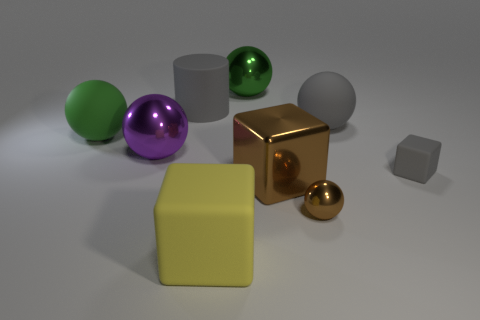There is a gray rubber thing that is in front of the metallic ball that is left of the yellow matte object; how big is it?
Offer a very short reply. Small. The small thing that is the same shape as the large purple metal thing is what color?
Give a very brief answer. Brown. Is the brown shiny sphere the same size as the gray rubber cube?
Your response must be concise. Yes. Are there the same number of small shiny things behind the gray cylinder and large purple objects?
Your answer should be very brief. No. Are there any gray rubber blocks that are in front of the matte cube that is to the right of the tiny sphere?
Offer a very short reply. No. How big is the green thing in front of the big gray object on the right side of the big matte object that is in front of the brown ball?
Ensure brevity in your answer.  Large. The gray thing that is in front of the big sphere that is left of the purple thing is made of what material?
Give a very brief answer. Rubber. Is there a gray object of the same shape as the purple thing?
Give a very brief answer. Yes. What is the shape of the large green matte object?
Offer a terse response. Sphere. There is a big brown block in front of the big gray object on the right side of the big rubber object in front of the tiny block; what is it made of?
Your answer should be compact. Metal. 